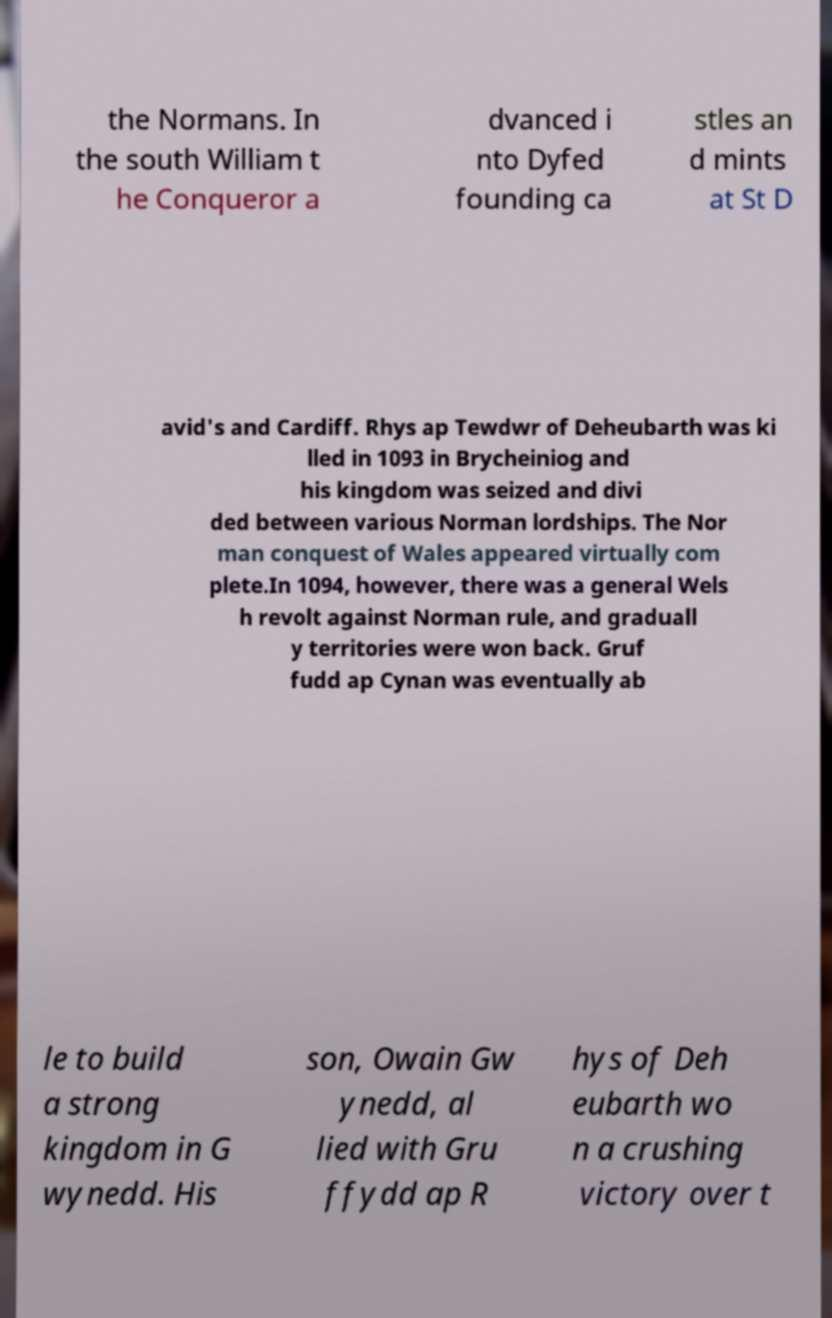For documentation purposes, I need the text within this image transcribed. Could you provide that? the Normans. In the south William t he Conqueror a dvanced i nto Dyfed founding ca stles an d mints at St D avid's and Cardiff. Rhys ap Tewdwr of Deheubarth was ki lled in 1093 in Brycheiniog and his kingdom was seized and divi ded between various Norman lordships. The Nor man conquest of Wales appeared virtually com plete.In 1094, however, there was a general Wels h revolt against Norman rule, and graduall y territories were won back. Gruf fudd ap Cynan was eventually ab le to build a strong kingdom in G wynedd. His son, Owain Gw ynedd, al lied with Gru ffydd ap R hys of Deh eubarth wo n a crushing victory over t 